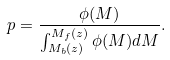<formula> <loc_0><loc_0><loc_500><loc_500>p = \frac { \phi ( M ) } { \int _ { M _ { b } ( z ) } ^ { M _ { f } ( z ) } \phi ( M ) d M } .</formula> 